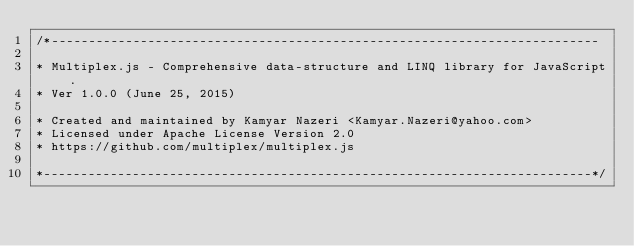<code> <loc_0><loc_0><loc_500><loc_500><_JavaScript_>/*--------------------------------------------------------------------------

* Multiplex.js - Comprehensive data-structure and LINQ library for JavaScript.
* Ver 1.0.0 (June 25, 2015)

* Created and maintained by Kamyar Nazeri <Kamyar.Nazeri@yahoo.com>
* Licensed under Apache License Version 2.0
* https://github.com/multiplex/multiplex.js

*--------------------------------------------------------------------------*/
</code> 